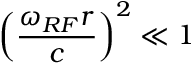Convert formula to latex. <formula><loc_0><loc_0><loc_500><loc_500>\left ( \frac { \omega _ { R F } r } { c } \right ) ^ { 2 } \ll 1</formula> 